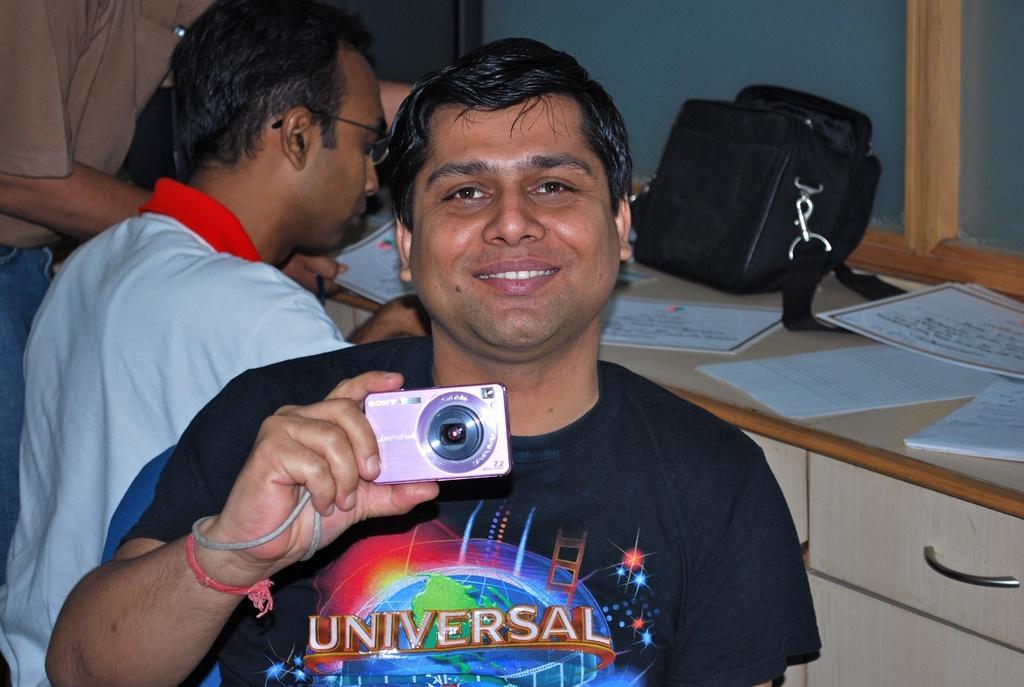Please provide a concise description of this image. In the foreground of this picture, there is a man in black T shirt holding a camera and having smile on his face. Behind him there are two men near a desk on which certificates, papers and a bag is placed on it. In the background, there is a wall. 